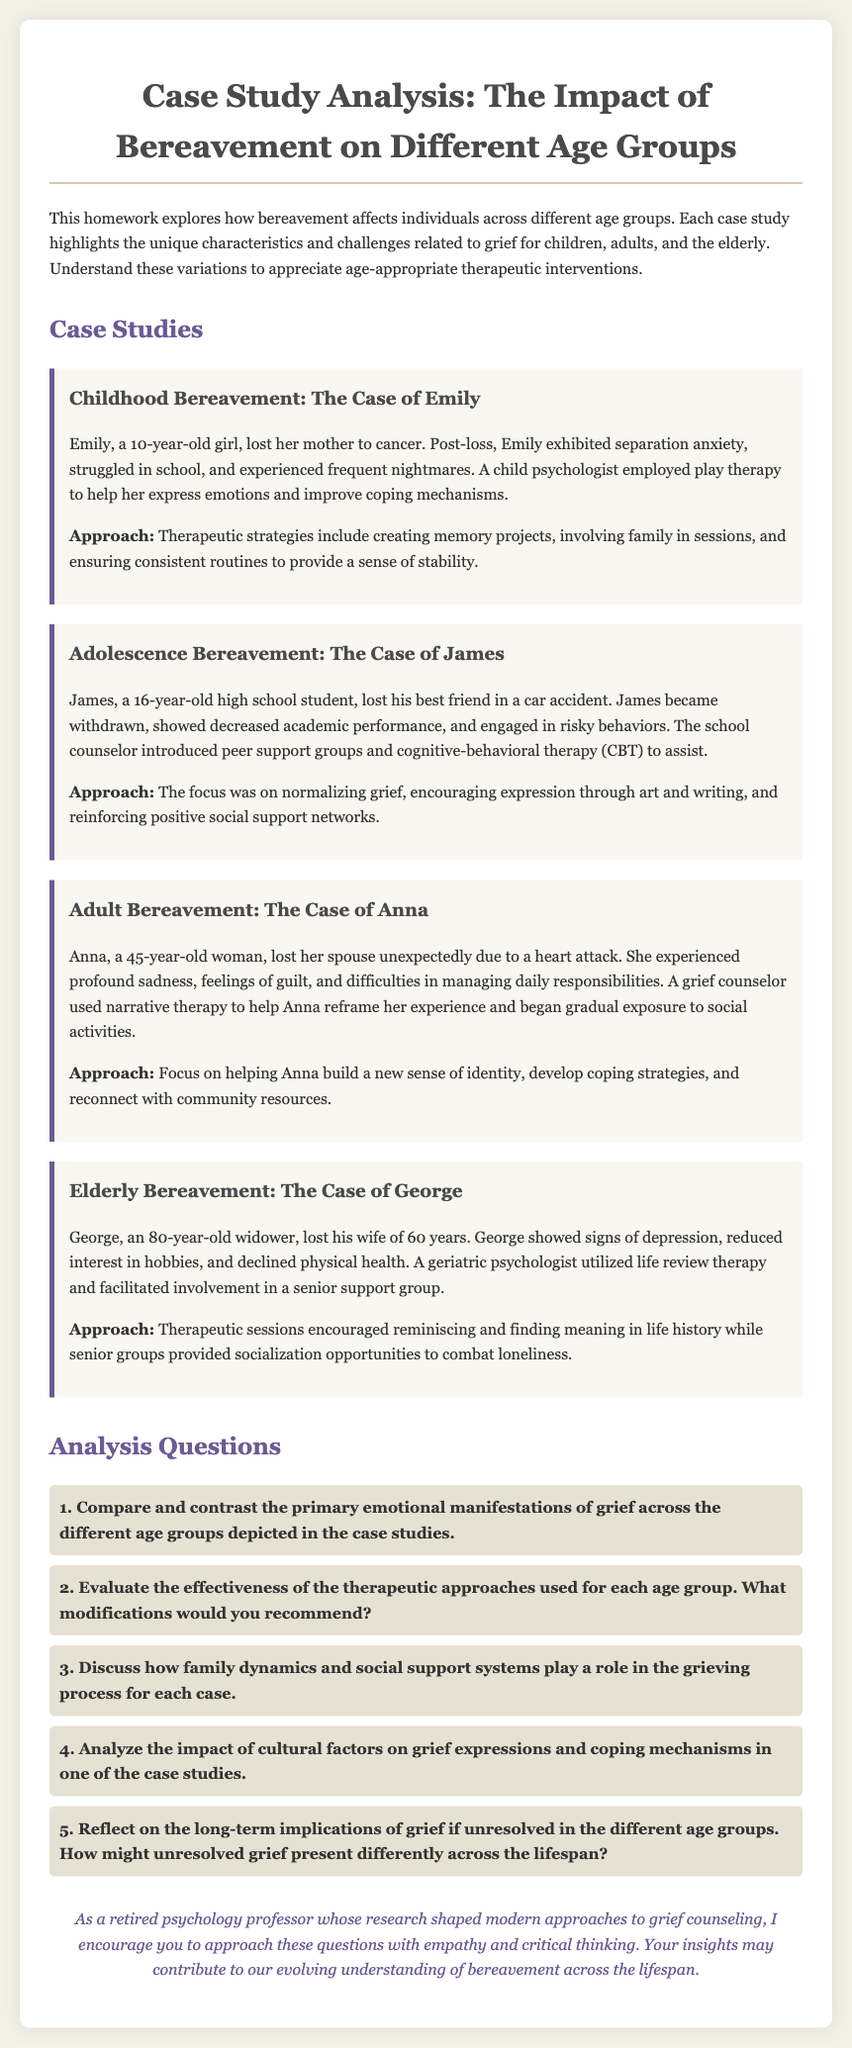1. What age is Emily? Emily is a 10-year-old girl as stated in her case study.
Answer: 10 years old 2. What type of therapy was used for Anna? The grief counselor used narrative therapy to assist Anna in her case study.
Answer: Narrative therapy 3. Who did James lose? James lost his best friend in a car accident, which is specified in his case study.
Answer: Best friend 4. What approach was used with George? A geriatric psychologist utilized life review therapy with George to help him process his grief.
Answer: Life review therapy 5. How long had George's wife been deceased? George's wife had been deceased for 60 years, as mentioned in his case study.
Answer: 60 years 